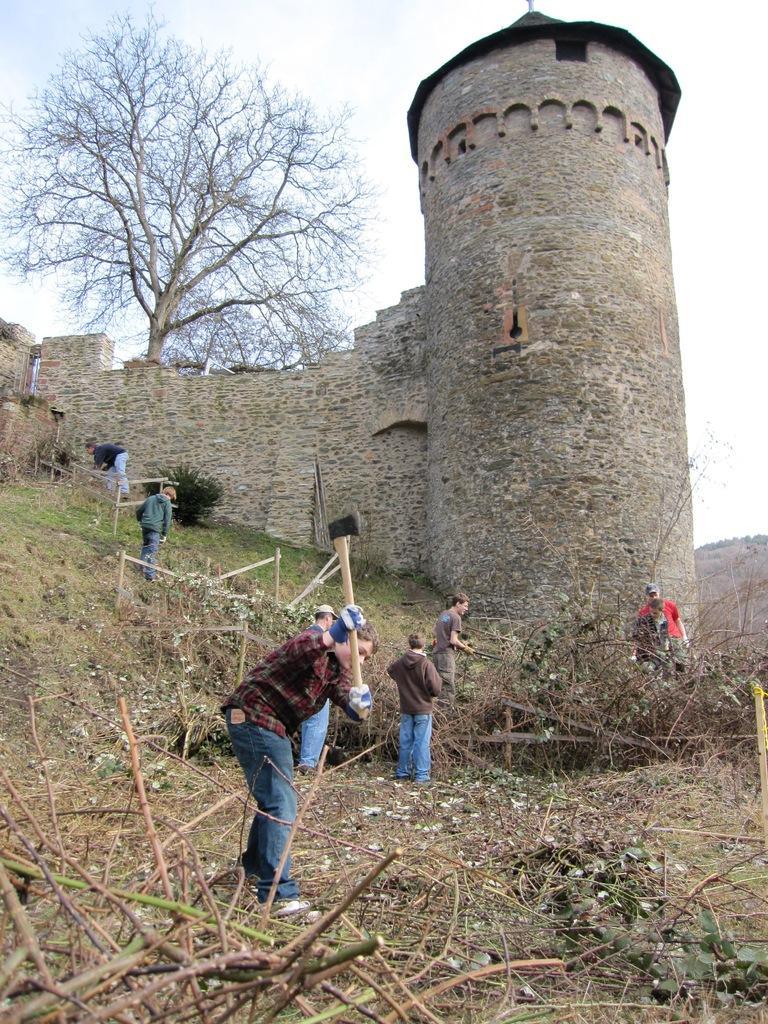Could you give a brief overview of what you see in this image? People are standing. A person is present at the front holding an axe. There is a stone building and a tree is present at the back. 